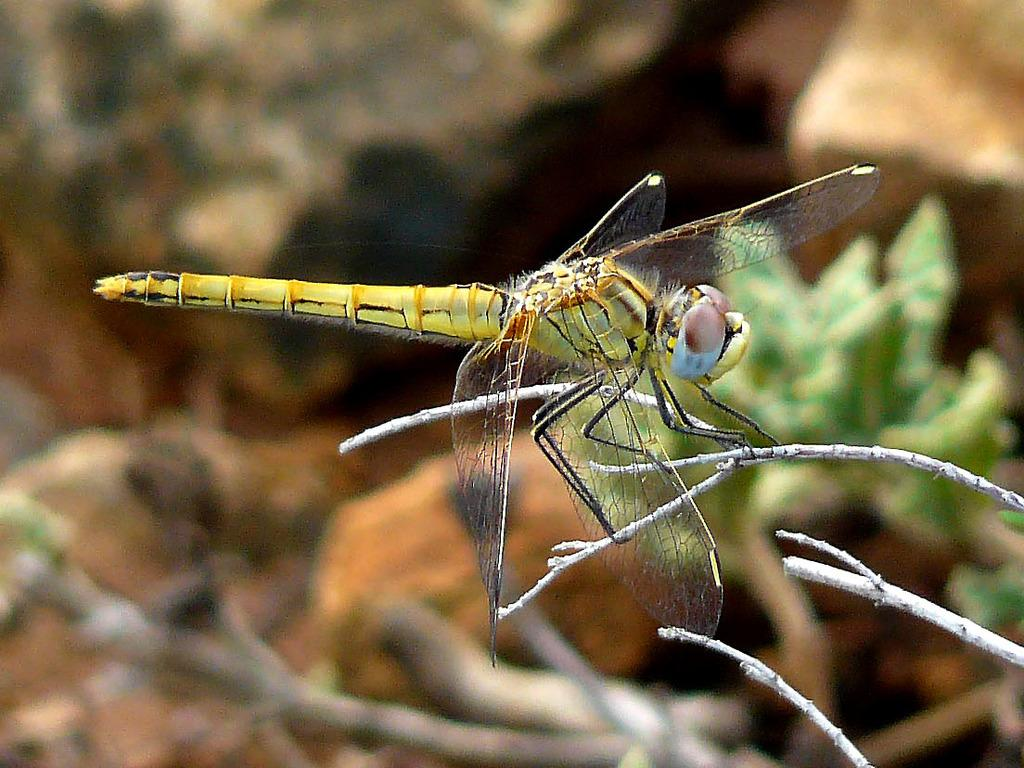What is present in the image? There is an insect in the image. Where is the insect located? The insect is on a tree. Can you describe the background of the image? The background of the image is blurred. What type of spoon can be seen in the image? There is no spoon present in the image. How does the insect sneeze in the image? Insects do not have the ability to sneeze, so this action cannot be observed in the image. 